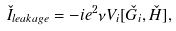<formula> <loc_0><loc_0><loc_500><loc_500>\check { I } _ { l e a k a g e } = - i e ^ { 2 } \nu V _ { i } [ \check { G } _ { i } , \check { H } ] ,</formula> 